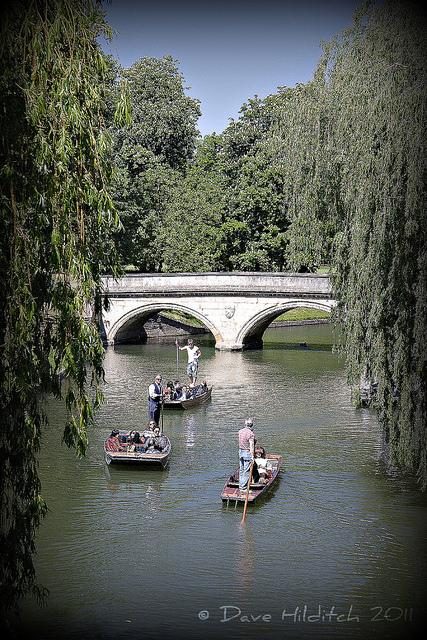Why are some people standing in the boats? balancing 